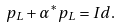Convert formula to latex. <formula><loc_0><loc_0><loc_500><loc_500>p _ { L } + \alpha ^ { * } p _ { L } = I d .</formula> 